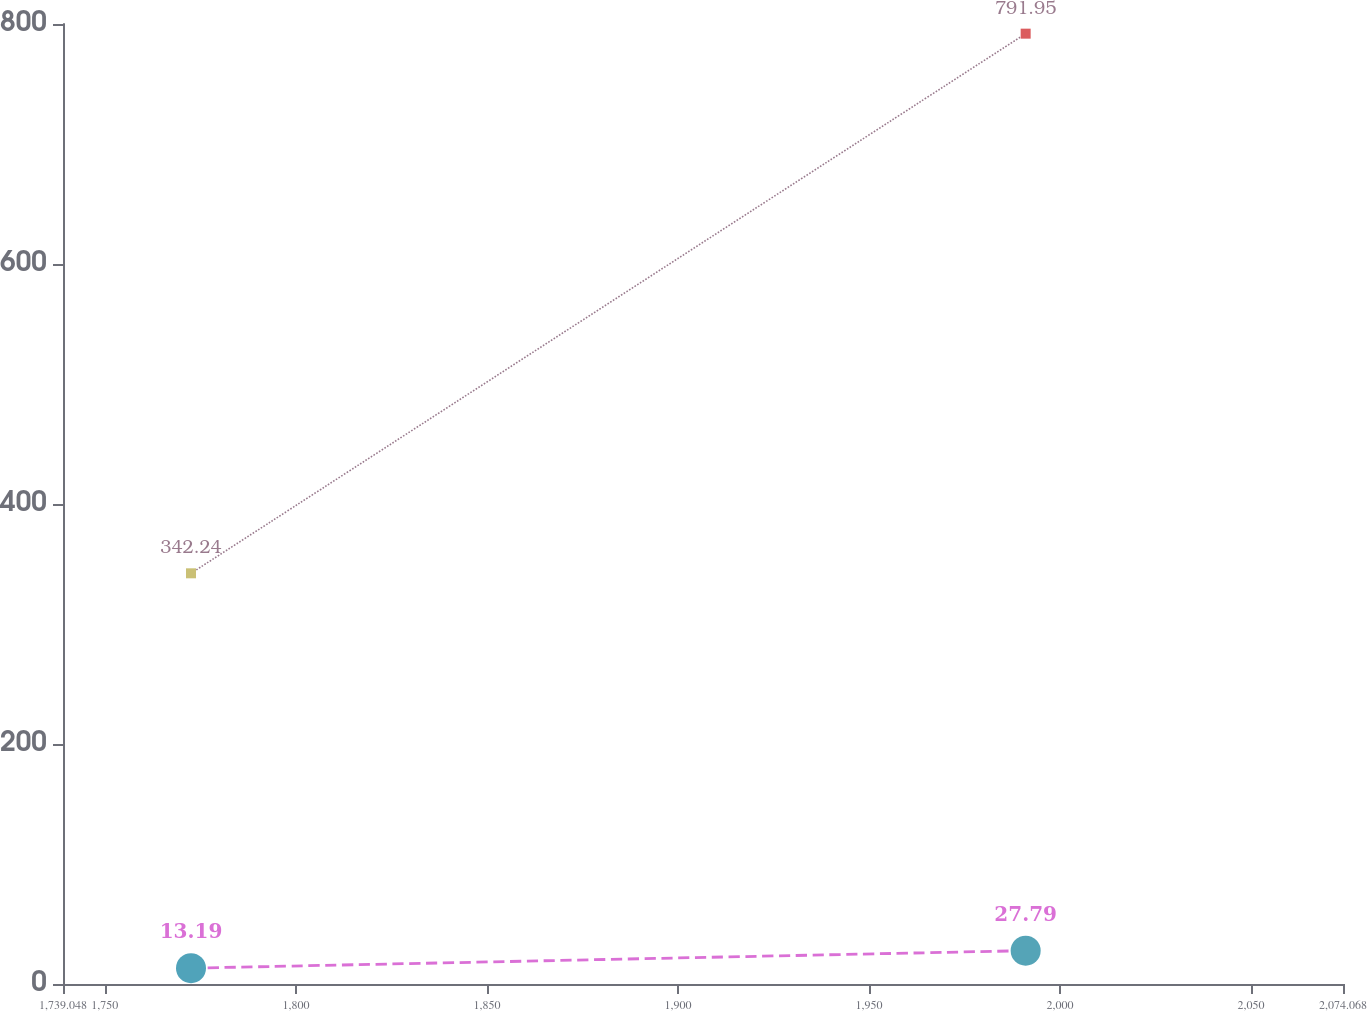Convert chart. <chart><loc_0><loc_0><loc_500><loc_500><line_chart><ecel><fcel>Effective Tax Rate<fcel>Provision for Income Taxes<nl><fcel>1772.55<fcel>13.19<fcel>342.24<nl><fcel>1991.01<fcel>27.79<fcel>791.95<nl><fcel>2107.57<fcel>24.56<fcel>841.56<nl></chart> 